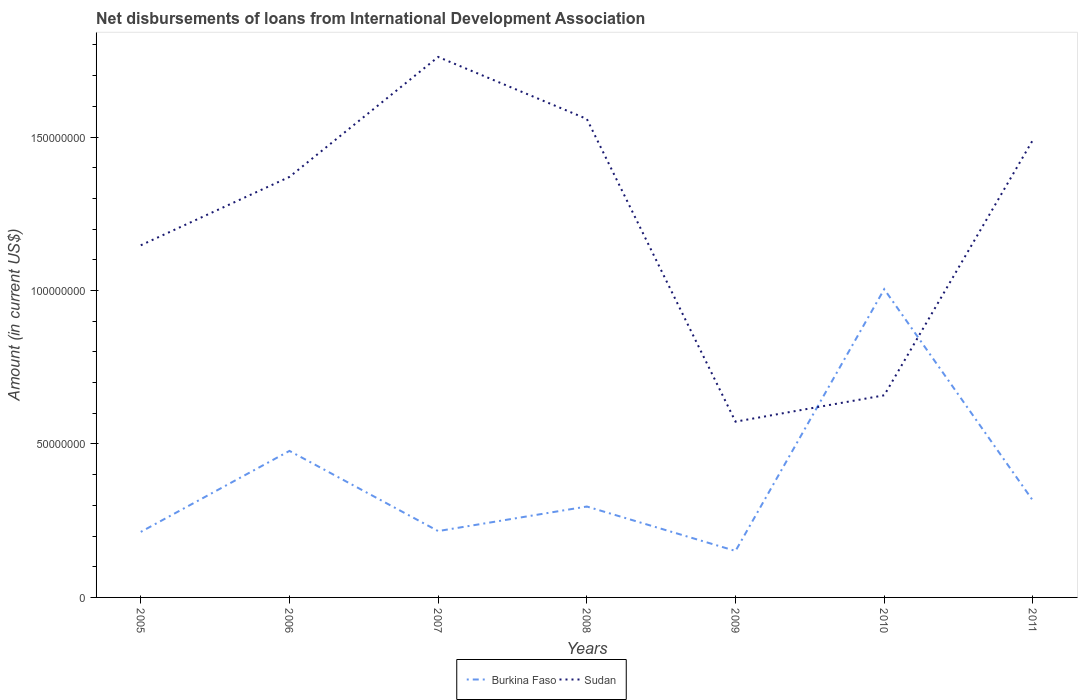Is the number of lines equal to the number of legend labels?
Keep it short and to the point. Yes. Across all years, what is the maximum amount of loans disbursed in Burkina Faso?
Offer a very short reply. 1.51e+07. What is the total amount of loans disbursed in Burkina Faso in the graph?
Your answer should be very brief. 2.61e+07. What is the difference between the highest and the second highest amount of loans disbursed in Sudan?
Offer a very short reply. 1.19e+08. How many years are there in the graph?
Your answer should be compact. 7. Does the graph contain any zero values?
Make the answer very short. No. What is the title of the graph?
Make the answer very short. Net disbursements of loans from International Development Association. What is the label or title of the Y-axis?
Ensure brevity in your answer.  Amount (in current US$). What is the Amount (in current US$) in Burkina Faso in 2005?
Ensure brevity in your answer.  2.13e+07. What is the Amount (in current US$) in Sudan in 2005?
Give a very brief answer. 1.15e+08. What is the Amount (in current US$) of Burkina Faso in 2006?
Your response must be concise. 4.77e+07. What is the Amount (in current US$) in Sudan in 2006?
Offer a very short reply. 1.37e+08. What is the Amount (in current US$) in Burkina Faso in 2007?
Keep it short and to the point. 2.16e+07. What is the Amount (in current US$) in Sudan in 2007?
Provide a short and direct response. 1.76e+08. What is the Amount (in current US$) in Burkina Faso in 2008?
Keep it short and to the point. 2.96e+07. What is the Amount (in current US$) in Sudan in 2008?
Make the answer very short. 1.56e+08. What is the Amount (in current US$) in Burkina Faso in 2009?
Offer a very short reply. 1.51e+07. What is the Amount (in current US$) of Sudan in 2009?
Your response must be concise. 5.73e+07. What is the Amount (in current US$) in Burkina Faso in 2010?
Keep it short and to the point. 1.00e+08. What is the Amount (in current US$) in Sudan in 2010?
Offer a terse response. 6.59e+07. What is the Amount (in current US$) in Burkina Faso in 2011?
Make the answer very short. 3.15e+07. What is the Amount (in current US$) of Sudan in 2011?
Your response must be concise. 1.49e+08. Across all years, what is the maximum Amount (in current US$) of Burkina Faso?
Make the answer very short. 1.00e+08. Across all years, what is the maximum Amount (in current US$) in Sudan?
Your answer should be very brief. 1.76e+08. Across all years, what is the minimum Amount (in current US$) of Burkina Faso?
Your answer should be very brief. 1.51e+07. Across all years, what is the minimum Amount (in current US$) in Sudan?
Offer a terse response. 5.73e+07. What is the total Amount (in current US$) in Burkina Faso in the graph?
Your answer should be very brief. 2.67e+08. What is the total Amount (in current US$) of Sudan in the graph?
Keep it short and to the point. 8.56e+08. What is the difference between the Amount (in current US$) of Burkina Faso in 2005 and that in 2006?
Your answer should be very brief. -2.64e+07. What is the difference between the Amount (in current US$) in Sudan in 2005 and that in 2006?
Your response must be concise. -2.23e+07. What is the difference between the Amount (in current US$) in Burkina Faso in 2005 and that in 2007?
Your answer should be compact. -2.67e+05. What is the difference between the Amount (in current US$) in Sudan in 2005 and that in 2007?
Offer a terse response. -6.14e+07. What is the difference between the Amount (in current US$) in Burkina Faso in 2005 and that in 2008?
Offer a very short reply. -8.27e+06. What is the difference between the Amount (in current US$) of Sudan in 2005 and that in 2008?
Ensure brevity in your answer.  -4.12e+07. What is the difference between the Amount (in current US$) of Burkina Faso in 2005 and that in 2009?
Offer a very short reply. 6.21e+06. What is the difference between the Amount (in current US$) in Sudan in 2005 and that in 2009?
Your response must be concise. 5.75e+07. What is the difference between the Amount (in current US$) in Burkina Faso in 2005 and that in 2010?
Provide a succinct answer. -7.91e+07. What is the difference between the Amount (in current US$) of Sudan in 2005 and that in 2010?
Offer a terse response. 4.89e+07. What is the difference between the Amount (in current US$) in Burkina Faso in 2005 and that in 2011?
Provide a short and direct response. -1.02e+07. What is the difference between the Amount (in current US$) of Sudan in 2005 and that in 2011?
Give a very brief answer. -3.43e+07. What is the difference between the Amount (in current US$) of Burkina Faso in 2006 and that in 2007?
Keep it short and to the point. 2.61e+07. What is the difference between the Amount (in current US$) of Sudan in 2006 and that in 2007?
Your response must be concise. -3.91e+07. What is the difference between the Amount (in current US$) in Burkina Faso in 2006 and that in 2008?
Provide a succinct answer. 1.81e+07. What is the difference between the Amount (in current US$) in Sudan in 2006 and that in 2008?
Keep it short and to the point. -1.89e+07. What is the difference between the Amount (in current US$) of Burkina Faso in 2006 and that in 2009?
Give a very brief answer. 3.26e+07. What is the difference between the Amount (in current US$) in Sudan in 2006 and that in 2009?
Make the answer very short. 7.97e+07. What is the difference between the Amount (in current US$) of Burkina Faso in 2006 and that in 2010?
Provide a short and direct response. -5.27e+07. What is the difference between the Amount (in current US$) in Sudan in 2006 and that in 2010?
Keep it short and to the point. 7.12e+07. What is the difference between the Amount (in current US$) of Burkina Faso in 2006 and that in 2011?
Your response must be concise. 1.62e+07. What is the difference between the Amount (in current US$) in Sudan in 2006 and that in 2011?
Keep it short and to the point. -1.20e+07. What is the difference between the Amount (in current US$) of Burkina Faso in 2007 and that in 2008?
Your response must be concise. -8.00e+06. What is the difference between the Amount (in current US$) in Sudan in 2007 and that in 2008?
Give a very brief answer. 2.02e+07. What is the difference between the Amount (in current US$) in Burkina Faso in 2007 and that in 2009?
Your answer should be very brief. 6.47e+06. What is the difference between the Amount (in current US$) in Sudan in 2007 and that in 2009?
Offer a terse response. 1.19e+08. What is the difference between the Amount (in current US$) of Burkina Faso in 2007 and that in 2010?
Offer a terse response. -7.88e+07. What is the difference between the Amount (in current US$) in Sudan in 2007 and that in 2010?
Your answer should be very brief. 1.10e+08. What is the difference between the Amount (in current US$) in Burkina Faso in 2007 and that in 2011?
Give a very brief answer. -9.93e+06. What is the difference between the Amount (in current US$) of Sudan in 2007 and that in 2011?
Ensure brevity in your answer.  2.70e+07. What is the difference between the Amount (in current US$) in Burkina Faso in 2008 and that in 2009?
Provide a short and direct response. 1.45e+07. What is the difference between the Amount (in current US$) of Sudan in 2008 and that in 2009?
Provide a succinct answer. 9.86e+07. What is the difference between the Amount (in current US$) of Burkina Faso in 2008 and that in 2010?
Provide a succinct answer. -7.08e+07. What is the difference between the Amount (in current US$) in Sudan in 2008 and that in 2010?
Ensure brevity in your answer.  9.00e+07. What is the difference between the Amount (in current US$) of Burkina Faso in 2008 and that in 2011?
Provide a short and direct response. -1.93e+06. What is the difference between the Amount (in current US$) in Sudan in 2008 and that in 2011?
Offer a terse response. 6.84e+06. What is the difference between the Amount (in current US$) in Burkina Faso in 2009 and that in 2010?
Provide a short and direct response. -8.53e+07. What is the difference between the Amount (in current US$) of Sudan in 2009 and that in 2010?
Ensure brevity in your answer.  -8.59e+06. What is the difference between the Amount (in current US$) of Burkina Faso in 2009 and that in 2011?
Your answer should be compact. -1.64e+07. What is the difference between the Amount (in current US$) of Sudan in 2009 and that in 2011?
Provide a succinct answer. -9.18e+07. What is the difference between the Amount (in current US$) of Burkina Faso in 2010 and that in 2011?
Give a very brief answer. 6.89e+07. What is the difference between the Amount (in current US$) in Sudan in 2010 and that in 2011?
Your response must be concise. -8.32e+07. What is the difference between the Amount (in current US$) in Burkina Faso in 2005 and the Amount (in current US$) in Sudan in 2006?
Provide a short and direct response. -1.16e+08. What is the difference between the Amount (in current US$) in Burkina Faso in 2005 and the Amount (in current US$) in Sudan in 2007?
Your response must be concise. -1.55e+08. What is the difference between the Amount (in current US$) in Burkina Faso in 2005 and the Amount (in current US$) in Sudan in 2008?
Offer a very short reply. -1.35e+08. What is the difference between the Amount (in current US$) in Burkina Faso in 2005 and the Amount (in current US$) in Sudan in 2009?
Your answer should be very brief. -3.59e+07. What is the difference between the Amount (in current US$) in Burkina Faso in 2005 and the Amount (in current US$) in Sudan in 2010?
Keep it short and to the point. -4.45e+07. What is the difference between the Amount (in current US$) in Burkina Faso in 2005 and the Amount (in current US$) in Sudan in 2011?
Offer a terse response. -1.28e+08. What is the difference between the Amount (in current US$) of Burkina Faso in 2006 and the Amount (in current US$) of Sudan in 2007?
Offer a terse response. -1.28e+08. What is the difference between the Amount (in current US$) in Burkina Faso in 2006 and the Amount (in current US$) in Sudan in 2008?
Offer a very short reply. -1.08e+08. What is the difference between the Amount (in current US$) of Burkina Faso in 2006 and the Amount (in current US$) of Sudan in 2009?
Keep it short and to the point. -9.53e+06. What is the difference between the Amount (in current US$) of Burkina Faso in 2006 and the Amount (in current US$) of Sudan in 2010?
Offer a very short reply. -1.81e+07. What is the difference between the Amount (in current US$) of Burkina Faso in 2006 and the Amount (in current US$) of Sudan in 2011?
Provide a short and direct response. -1.01e+08. What is the difference between the Amount (in current US$) in Burkina Faso in 2007 and the Amount (in current US$) in Sudan in 2008?
Your answer should be very brief. -1.34e+08. What is the difference between the Amount (in current US$) of Burkina Faso in 2007 and the Amount (in current US$) of Sudan in 2009?
Ensure brevity in your answer.  -3.56e+07. What is the difference between the Amount (in current US$) in Burkina Faso in 2007 and the Amount (in current US$) in Sudan in 2010?
Your answer should be very brief. -4.42e+07. What is the difference between the Amount (in current US$) in Burkina Faso in 2007 and the Amount (in current US$) in Sudan in 2011?
Offer a terse response. -1.27e+08. What is the difference between the Amount (in current US$) in Burkina Faso in 2008 and the Amount (in current US$) in Sudan in 2009?
Offer a very short reply. -2.77e+07. What is the difference between the Amount (in current US$) of Burkina Faso in 2008 and the Amount (in current US$) of Sudan in 2010?
Offer a very short reply. -3.62e+07. What is the difference between the Amount (in current US$) in Burkina Faso in 2008 and the Amount (in current US$) in Sudan in 2011?
Your response must be concise. -1.19e+08. What is the difference between the Amount (in current US$) of Burkina Faso in 2009 and the Amount (in current US$) of Sudan in 2010?
Provide a short and direct response. -5.07e+07. What is the difference between the Amount (in current US$) in Burkina Faso in 2009 and the Amount (in current US$) in Sudan in 2011?
Your answer should be very brief. -1.34e+08. What is the difference between the Amount (in current US$) in Burkina Faso in 2010 and the Amount (in current US$) in Sudan in 2011?
Provide a short and direct response. -4.86e+07. What is the average Amount (in current US$) of Burkina Faso per year?
Provide a short and direct response. 3.82e+07. What is the average Amount (in current US$) of Sudan per year?
Provide a short and direct response. 1.22e+08. In the year 2005, what is the difference between the Amount (in current US$) of Burkina Faso and Amount (in current US$) of Sudan?
Provide a succinct answer. -9.34e+07. In the year 2006, what is the difference between the Amount (in current US$) of Burkina Faso and Amount (in current US$) of Sudan?
Give a very brief answer. -8.93e+07. In the year 2007, what is the difference between the Amount (in current US$) in Burkina Faso and Amount (in current US$) in Sudan?
Your response must be concise. -1.54e+08. In the year 2008, what is the difference between the Amount (in current US$) of Burkina Faso and Amount (in current US$) of Sudan?
Your answer should be compact. -1.26e+08. In the year 2009, what is the difference between the Amount (in current US$) of Burkina Faso and Amount (in current US$) of Sudan?
Your answer should be compact. -4.21e+07. In the year 2010, what is the difference between the Amount (in current US$) in Burkina Faso and Amount (in current US$) in Sudan?
Provide a short and direct response. 3.46e+07. In the year 2011, what is the difference between the Amount (in current US$) of Burkina Faso and Amount (in current US$) of Sudan?
Provide a succinct answer. -1.17e+08. What is the ratio of the Amount (in current US$) in Burkina Faso in 2005 to that in 2006?
Offer a very short reply. 0.45. What is the ratio of the Amount (in current US$) in Sudan in 2005 to that in 2006?
Your answer should be compact. 0.84. What is the ratio of the Amount (in current US$) of Burkina Faso in 2005 to that in 2007?
Keep it short and to the point. 0.99. What is the ratio of the Amount (in current US$) in Sudan in 2005 to that in 2007?
Provide a succinct answer. 0.65. What is the ratio of the Amount (in current US$) of Burkina Faso in 2005 to that in 2008?
Your answer should be very brief. 0.72. What is the ratio of the Amount (in current US$) in Sudan in 2005 to that in 2008?
Give a very brief answer. 0.74. What is the ratio of the Amount (in current US$) of Burkina Faso in 2005 to that in 2009?
Your response must be concise. 1.41. What is the ratio of the Amount (in current US$) in Sudan in 2005 to that in 2009?
Offer a very short reply. 2. What is the ratio of the Amount (in current US$) in Burkina Faso in 2005 to that in 2010?
Your response must be concise. 0.21. What is the ratio of the Amount (in current US$) in Sudan in 2005 to that in 2010?
Keep it short and to the point. 1.74. What is the ratio of the Amount (in current US$) in Burkina Faso in 2005 to that in 2011?
Your answer should be very brief. 0.68. What is the ratio of the Amount (in current US$) of Sudan in 2005 to that in 2011?
Make the answer very short. 0.77. What is the ratio of the Amount (in current US$) in Burkina Faso in 2006 to that in 2007?
Your response must be concise. 2.21. What is the ratio of the Amount (in current US$) of Sudan in 2006 to that in 2007?
Give a very brief answer. 0.78. What is the ratio of the Amount (in current US$) of Burkina Faso in 2006 to that in 2008?
Make the answer very short. 1.61. What is the ratio of the Amount (in current US$) in Sudan in 2006 to that in 2008?
Provide a short and direct response. 0.88. What is the ratio of the Amount (in current US$) of Burkina Faso in 2006 to that in 2009?
Offer a terse response. 3.15. What is the ratio of the Amount (in current US$) in Sudan in 2006 to that in 2009?
Ensure brevity in your answer.  2.39. What is the ratio of the Amount (in current US$) of Burkina Faso in 2006 to that in 2010?
Give a very brief answer. 0.48. What is the ratio of the Amount (in current US$) in Sudan in 2006 to that in 2010?
Provide a short and direct response. 2.08. What is the ratio of the Amount (in current US$) of Burkina Faso in 2006 to that in 2011?
Offer a terse response. 1.51. What is the ratio of the Amount (in current US$) of Sudan in 2006 to that in 2011?
Ensure brevity in your answer.  0.92. What is the ratio of the Amount (in current US$) of Burkina Faso in 2007 to that in 2008?
Make the answer very short. 0.73. What is the ratio of the Amount (in current US$) in Sudan in 2007 to that in 2008?
Provide a short and direct response. 1.13. What is the ratio of the Amount (in current US$) in Burkina Faso in 2007 to that in 2009?
Your answer should be compact. 1.43. What is the ratio of the Amount (in current US$) in Sudan in 2007 to that in 2009?
Your response must be concise. 3.07. What is the ratio of the Amount (in current US$) in Burkina Faso in 2007 to that in 2010?
Your answer should be compact. 0.22. What is the ratio of the Amount (in current US$) in Sudan in 2007 to that in 2010?
Provide a short and direct response. 2.67. What is the ratio of the Amount (in current US$) of Burkina Faso in 2007 to that in 2011?
Provide a succinct answer. 0.69. What is the ratio of the Amount (in current US$) of Sudan in 2007 to that in 2011?
Your answer should be compact. 1.18. What is the ratio of the Amount (in current US$) of Burkina Faso in 2008 to that in 2009?
Ensure brevity in your answer.  1.96. What is the ratio of the Amount (in current US$) in Sudan in 2008 to that in 2009?
Ensure brevity in your answer.  2.72. What is the ratio of the Amount (in current US$) in Burkina Faso in 2008 to that in 2010?
Provide a succinct answer. 0.29. What is the ratio of the Amount (in current US$) in Sudan in 2008 to that in 2010?
Your response must be concise. 2.37. What is the ratio of the Amount (in current US$) in Burkina Faso in 2008 to that in 2011?
Offer a terse response. 0.94. What is the ratio of the Amount (in current US$) in Sudan in 2008 to that in 2011?
Offer a very short reply. 1.05. What is the ratio of the Amount (in current US$) in Burkina Faso in 2009 to that in 2010?
Ensure brevity in your answer.  0.15. What is the ratio of the Amount (in current US$) in Sudan in 2009 to that in 2010?
Make the answer very short. 0.87. What is the ratio of the Amount (in current US$) in Burkina Faso in 2009 to that in 2011?
Offer a very short reply. 0.48. What is the ratio of the Amount (in current US$) in Sudan in 2009 to that in 2011?
Provide a short and direct response. 0.38. What is the ratio of the Amount (in current US$) of Burkina Faso in 2010 to that in 2011?
Make the answer very short. 3.18. What is the ratio of the Amount (in current US$) of Sudan in 2010 to that in 2011?
Give a very brief answer. 0.44. What is the difference between the highest and the second highest Amount (in current US$) in Burkina Faso?
Provide a succinct answer. 5.27e+07. What is the difference between the highest and the second highest Amount (in current US$) of Sudan?
Your response must be concise. 2.02e+07. What is the difference between the highest and the lowest Amount (in current US$) in Burkina Faso?
Make the answer very short. 8.53e+07. What is the difference between the highest and the lowest Amount (in current US$) in Sudan?
Your response must be concise. 1.19e+08. 